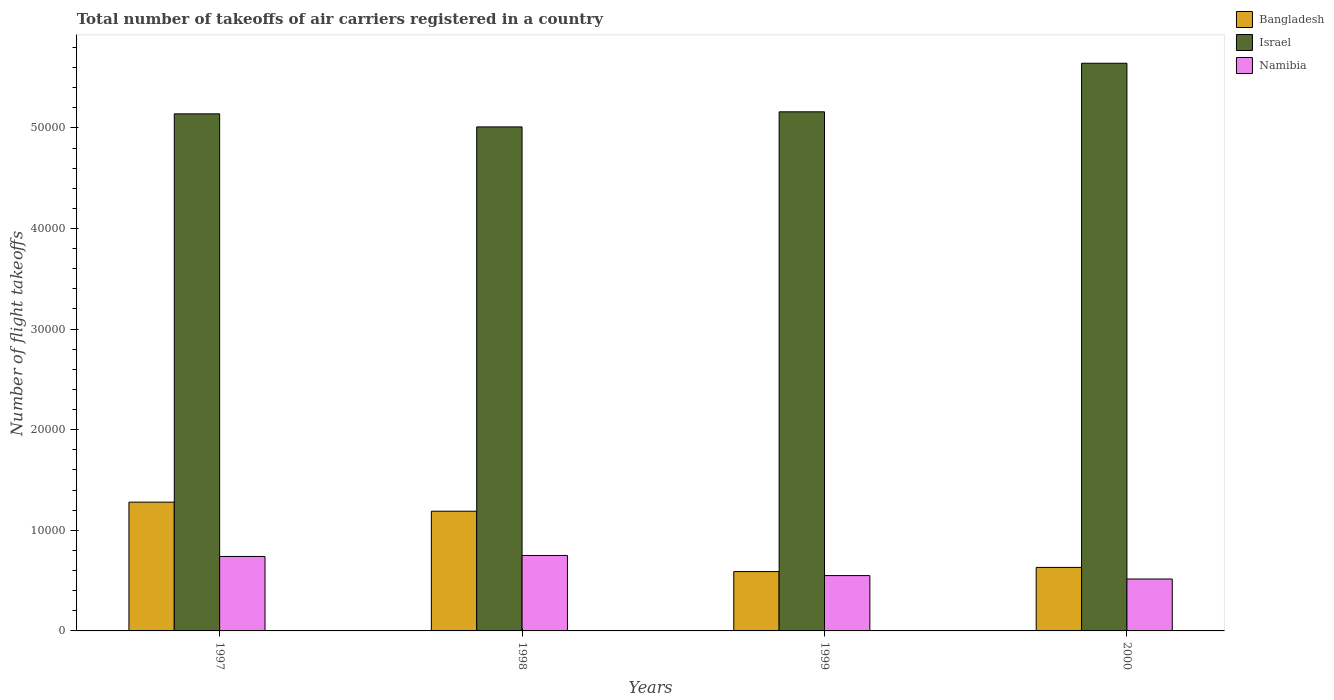How many groups of bars are there?
Provide a succinct answer. 4. Are the number of bars per tick equal to the number of legend labels?
Make the answer very short. Yes. Are the number of bars on each tick of the X-axis equal?
Ensure brevity in your answer.  Yes. How many bars are there on the 4th tick from the right?
Your answer should be compact. 3. In how many cases, is the number of bars for a given year not equal to the number of legend labels?
Offer a terse response. 0. What is the total number of flight takeoffs in Bangladesh in 1997?
Your answer should be very brief. 1.28e+04. Across all years, what is the maximum total number of flight takeoffs in Israel?
Your response must be concise. 5.64e+04. Across all years, what is the minimum total number of flight takeoffs in Israel?
Your response must be concise. 5.01e+04. In which year was the total number of flight takeoffs in Bangladesh maximum?
Make the answer very short. 1997. In which year was the total number of flight takeoffs in Israel minimum?
Your answer should be very brief. 1998. What is the total total number of flight takeoffs in Bangladesh in the graph?
Provide a succinct answer. 3.69e+04. What is the difference between the total number of flight takeoffs in Bangladesh in 1999 and that in 2000?
Offer a very short reply. -413. What is the difference between the total number of flight takeoffs in Bangladesh in 2000 and the total number of flight takeoffs in Israel in 1999?
Keep it short and to the point. -4.53e+04. What is the average total number of flight takeoffs in Israel per year?
Offer a terse response. 5.24e+04. In the year 1997, what is the difference between the total number of flight takeoffs in Bangladesh and total number of flight takeoffs in Israel?
Your answer should be compact. -3.86e+04. What is the ratio of the total number of flight takeoffs in Namibia in 1998 to that in 2000?
Make the answer very short. 1.45. Is the difference between the total number of flight takeoffs in Bangladesh in 1997 and 1999 greater than the difference between the total number of flight takeoffs in Israel in 1997 and 1999?
Ensure brevity in your answer.  Yes. What is the difference between the highest and the second highest total number of flight takeoffs in Namibia?
Provide a short and direct response. 100. What is the difference between the highest and the lowest total number of flight takeoffs in Namibia?
Keep it short and to the point. 2339. Is the sum of the total number of flight takeoffs in Bangladesh in 1998 and 2000 greater than the maximum total number of flight takeoffs in Israel across all years?
Give a very brief answer. No. What does the 2nd bar from the left in 1997 represents?
Your response must be concise. Israel. What does the 2nd bar from the right in 2000 represents?
Your answer should be very brief. Israel. How many bars are there?
Keep it short and to the point. 12. Are all the bars in the graph horizontal?
Offer a terse response. No. What is the difference between two consecutive major ticks on the Y-axis?
Provide a succinct answer. 10000. Does the graph contain any zero values?
Provide a succinct answer. No. Does the graph contain grids?
Your response must be concise. No. What is the title of the graph?
Your answer should be compact. Total number of takeoffs of air carriers registered in a country. What is the label or title of the X-axis?
Your response must be concise. Years. What is the label or title of the Y-axis?
Provide a short and direct response. Number of flight takeoffs. What is the Number of flight takeoffs of Bangladesh in 1997?
Provide a short and direct response. 1.28e+04. What is the Number of flight takeoffs in Israel in 1997?
Your answer should be compact. 5.14e+04. What is the Number of flight takeoffs in Namibia in 1997?
Ensure brevity in your answer.  7400. What is the Number of flight takeoffs of Bangladesh in 1998?
Keep it short and to the point. 1.19e+04. What is the Number of flight takeoffs in Israel in 1998?
Provide a succinct answer. 5.01e+04. What is the Number of flight takeoffs in Namibia in 1998?
Offer a terse response. 7500. What is the Number of flight takeoffs of Bangladesh in 1999?
Provide a succinct answer. 5900. What is the Number of flight takeoffs in Israel in 1999?
Give a very brief answer. 5.16e+04. What is the Number of flight takeoffs in Namibia in 1999?
Offer a very short reply. 5500. What is the Number of flight takeoffs of Bangladesh in 2000?
Provide a succinct answer. 6313. What is the Number of flight takeoffs of Israel in 2000?
Provide a short and direct response. 5.64e+04. What is the Number of flight takeoffs of Namibia in 2000?
Provide a short and direct response. 5161. Across all years, what is the maximum Number of flight takeoffs of Bangladesh?
Keep it short and to the point. 1.28e+04. Across all years, what is the maximum Number of flight takeoffs in Israel?
Give a very brief answer. 5.64e+04. Across all years, what is the maximum Number of flight takeoffs in Namibia?
Offer a terse response. 7500. Across all years, what is the minimum Number of flight takeoffs of Bangladesh?
Make the answer very short. 5900. Across all years, what is the minimum Number of flight takeoffs in Israel?
Ensure brevity in your answer.  5.01e+04. Across all years, what is the minimum Number of flight takeoffs of Namibia?
Make the answer very short. 5161. What is the total Number of flight takeoffs in Bangladesh in the graph?
Your answer should be compact. 3.69e+04. What is the total Number of flight takeoffs in Israel in the graph?
Keep it short and to the point. 2.10e+05. What is the total Number of flight takeoffs of Namibia in the graph?
Offer a very short reply. 2.56e+04. What is the difference between the Number of flight takeoffs of Bangladesh in 1997 and that in 1998?
Keep it short and to the point. 900. What is the difference between the Number of flight takeoffs of Israel in 1997 and that in 1998?
Offer a very short reply. 1300. What is the difference between the Number of flight takeoffs in Namibia in 1997 and that in 1998?
Provide a succinct answer. -100. What is the difference between the Number of flight takeoffs in Bangladesh in 1997 and that in 1999?
Your answer should be very brief. 6900. What is the difference between the Number of flight takeoffs of Israel in 1997 and that in 1999?
Your answer should be very brief. -200. What is the difference between the Number of flight takeoffs of Namibia in 1997 and that in 1999?
Make the answer very short. 1900. What is the difference between the Number of flight takeoffs in Bangladesh in 1997 and that in 2000?
Your response must be concise. 6487. What is the difference between the Number of flight takeoffs in Israel in 1997 and that in 2000?
Your response must be concise. -5027. What is the difference between the Number of flight takeoffs of Namibia in 1997 and that in 2000?
Make the answer very short. 2239. What is the difference between the Number of flight takeoffs in Bangladesh in 1998 and that in 1999?
Provide a succinct answer. 6000. What is the difference between the Number of flight takeoffs in Israel in 1998 and that in 1999?
Offer a terse response. -1500. What is the difference between the Number of flight takeoffs in Bangladesh in 1998 and that in 2000?
Your answer should be very brief. 5587. What is the difference between the Number of flight takeoffs in Israel in 1998 and that in 2000?
Give a very brief answer. -6327. What is the difference between the Number of flight takeoffs in Namibia in 1998 and that in 2000?
Give a very brief answer. 2339. What is the difference between the Number of flight takeoffs of Bangladesh in 1999 and that in 2000?
Your answer should be very brief. -413. What is the difference between the Number of flight takeoffs of Israel in 1999 and that in 2000?
Give a very brief answer. -4827. What is the difference between the Number of flight takeoffs of Namibia in 1999 and that in 2000?
Make the answer very short. 339. What is the difference between the Number of flight takeoffs of Bangladesh in 1997 and the Number of flight takeoffs of Israel in 1998?
Your response must be concise. -3.73e+04. What is the difference between the Number of flight takeoffs in Bangladesh in 1997 and the Number of flight takeoffs in Namibia in 1998?
Your answer should be very brief. 5300. What is the difference between the Number of flight takeoffs in Israel in 1997 and the Number of flight takeoffs in Namibia in 1998?
Offer a very short reply. 4.39e+04. What is the difference between the Number of flight takeoffs of Bangladesh in 1997 and the Number of flight takeoffs of Israel in 1999?
Your answer should be very brief. -3.88e+04. What is the difference between the Number of flight takeoffs in Bangladesh in 1997 and the Number of flight takeoffs in Namibia in 1999?
Provide a succinct answer. 7300. What is the difference between the Number of flight takeoffs of Israel in 1997 and the Number of flight takeoffs of Namibia in 1999?
Your answer should be compact. 4.59e+04. What is the difference between the Number of flight takeoffs in Bangladesh in 1997 and the Number of flight takeoffs in Israel in 2000?
Offer a very short reply. -4.36e+04. What is the difference between the Number of flight takeoffs in Bangladesh in 1997 and the Number of flight takeoffs in Namibia in 2000?
Offer a very short reply. 7639. What is the difference between the Number of flight takeoffs in Israel in 1997 and the Number of flight takeoffs in Namibia in 2000?
Your answer should be compact. 4.62e+04. What is the difference between the Number of flight takeoffs in Bangladesh in 1998 and the Number of flight takeoffs in Israel in 1999?
Keep it short and to the point. -3.97e+04. What is the difference between the Number of flight takeoffs in Bangladesh in 1998 and the Number of flight takeoffs in Namibia in 1999?
Give a very brief answer. 6400. What is the difference between the Number of flight takeoffs in Israel in 1998 and the Number of flight takeoffs in Namibia in 1999?
Provide a short and direct response. 4.46e+04. What is the difference between the Number of flight takeoffs in Bangladesh in 1998 and the Number of flight takeoffs in Israel in 2000?
Ensure brevity in your answer.  -4.45e+04. What is the difference between the Number of flight takeoffs in Bangladesh in 1998 and the Number of flight takeoffs in Namibia in 2000?
Make the answer very short. 6739. What is the difference between the Number of flight takeoffs in Israel in 1998 and the Number of flight takeoffs in Namibia in 2000?
Keep it short and to the point. 4.49e+04. What is the difference between the Number of flight takeoffs of Bangladesh in 1999 and the Number of flight takeoffs of Israel in 2000?
Provide a succinct answer. -5.05e+04. What is the difference between the Number of flight takeoffs in Bangladesh in 1999 and the Number of flight takeoffs in Namibia in 2000?
Your answer should be compact. 739. What is the difference between the Number of flight takeoffs of Israel in 1999 and the Number of flight takeoffs of Namibia in 2000?
Provide a short and direct response. 4.64e+04. What is the average Number of flight takeoffs in Bangladesh per year?
Keep it short and to the point. 9228.25. What is the average Number of flight takeoffs in Israel per year?
Your answer should be compact. 5.24e+04. What is the average Number of flight takeoffs in Namibia per year?
Ensure brevity in your answer.  6390.25. In the year 1997, what is the difference between the Number of flight takeoffs in Bangladesh and Number of flight takeoffs in Israel?
Your answer should be compact. -3.86e+04. In the year 1997, what is the difference between the Number of flight takeoffs of Bangladesh and Number of flight takeoffs of Namibia?
Give a very brief answer. 5400. In the year 1997, what is the difference between the Number of flight takeoffs of Israel and Number of flight takeoffs of Namibia?
Offer a terse response. 4.40e+04. In the year 1998, what is the difference between the Number of flight takeoffs in Bangladesh and Number of flight takeoffs in Israel?
Ensure brevity in your answer.  -3.82e+04. In the year 1998, what is the difference between the Number of flight takeoffs in Bangladesh and Number of flight takeoffs in Namibia?
Give a very brief answer. 4400. In the year 1998, what is the difference between the Number of flight takeoffs in Israel and Number of flight takeoffs in Namibia?
Your response must be concise. 4.26e+04. In the year 1999, what is the difference between the Number of flight takeoffs of Bangladesh and Number of flight takeoffs of Israel?
Provide a succinct answer. -4.57e+04. In the year 1999, what is the difference between the Number of flight takeoffs in Bangladesh and Number of flight takeoffs in Namibia?
Your answer should be compact. 400. In the year 1999, what is the difference between the Number of flight takeoffs in Israel and Number of flight takeoffs in Namibia?
Offer a terse response. 4.61e+04. In the year 2000, what is the difference between the Number of flight takeoffs of Bangladesh and Number of flight takeoffs of Israel?
Your response must be concise. -5.01e+04. In the year 2000, what is the difference between the Number of flight takeoffs of Bangladesh and Number of flight takeoffs of Namibia?
Provide a succinct answer. 1152. In the year 2000, what is the difference between the Number of flight takeoffs of Israel and Number of flight takeoffs of Namibia?
Your response must be concise. 5.13e+04. What is the ratio of the Number of flight takeoffs of Bangladesh in 1997 to that in 1998?
Keep it short and to the point. 1.08. What is the ratio of the Number of flight takeoffs of Israel in 1997 to that in 1998?
Make the answer very short. 1.03. What is the ratio of the Number of flight takeoffs in Namibia in 1997 to that in 1998?
Give a very brief answer. 0.99. What is the ratio of the Number of flight takeoffs of Bangladesh in 1997 to that in 1999?
Make the answer very short. 2.17. What is the ratio of the Number of flight takeoffs of Namibia in 1997 to that in 1999?
Offer a very short reply. 1.35. What is the ratio of the Number of flight takeoffs in Bangladesh in 1997 to that in 2000?
Ensure brevity in your answer.  2.03. What is the ratio of the Number of flight takeoffs of Israel in 1997 to that in 2000?
Your response must be concise. 0.91. What is the ratio of the Number of flight takeoffs in Namibia in 1997 to that in 2000?
Provide a short and direct response. 1.43. What is the ratio of the Number of flight takeoffs of Bangladesh in 1998 to that in 1999?
Offer a terse response. 2.02. What is the ratio of the Number of flight takeoffs of Israel in 1998 to that in 1999?
Ensure brevity in your answer.  0.97. What is the ratio of the Number of flight takeoffs of Namibia in 1998 to that in 1999?
Provide a succinct answer. 1.36. What is the ratio of the Number of flight takeoffs in Bangladesh in 1998 to that in 2000?
Your answer should be very brief. 1.89. What is the ratio of the Number of flight takeoffs of Israel in 1998 to that in 2000?
Make the answer very short. 0.89. What is the ratio of the Number of flight takeoffs of Namibia in 1998 to that in 2000?
Your response must be concise. 1.45. What is the ratio of the Number of flight takeoffs in Bangladesh in 1999 to that in 2000?
Your answer should be very brief. 0.93. What is the ratio of the Number of flight takeoffs of Israel in 1999 to that in 2000?
Make the answer very short. 0.91. What is the ratio of the Number of flight takeoffs in Namibia in 1999 to that in 2000?
Ensure brevity in your answer.  1.07. What is the difference between the highest and the second highest Number of flight takeoffs in Bangladesh?
Offer a terse response. 900. What is the difference between the highest and the second highest Number of flight takeoffs in Israel?
Your answer should be very brief. 4827. What is the difference between the highest and the lowest Number of flight takeoffs in Bangladesh?
Your response must be concise. 6900. What is the difference between the highest and the lowest Number of flight takeoffs in Israel?
Provide a short and direct response. 6327. What is the difference between the highest and the lowest Number of flight takeoffs in Namibia?
Keep it short and to the point. 2339. 